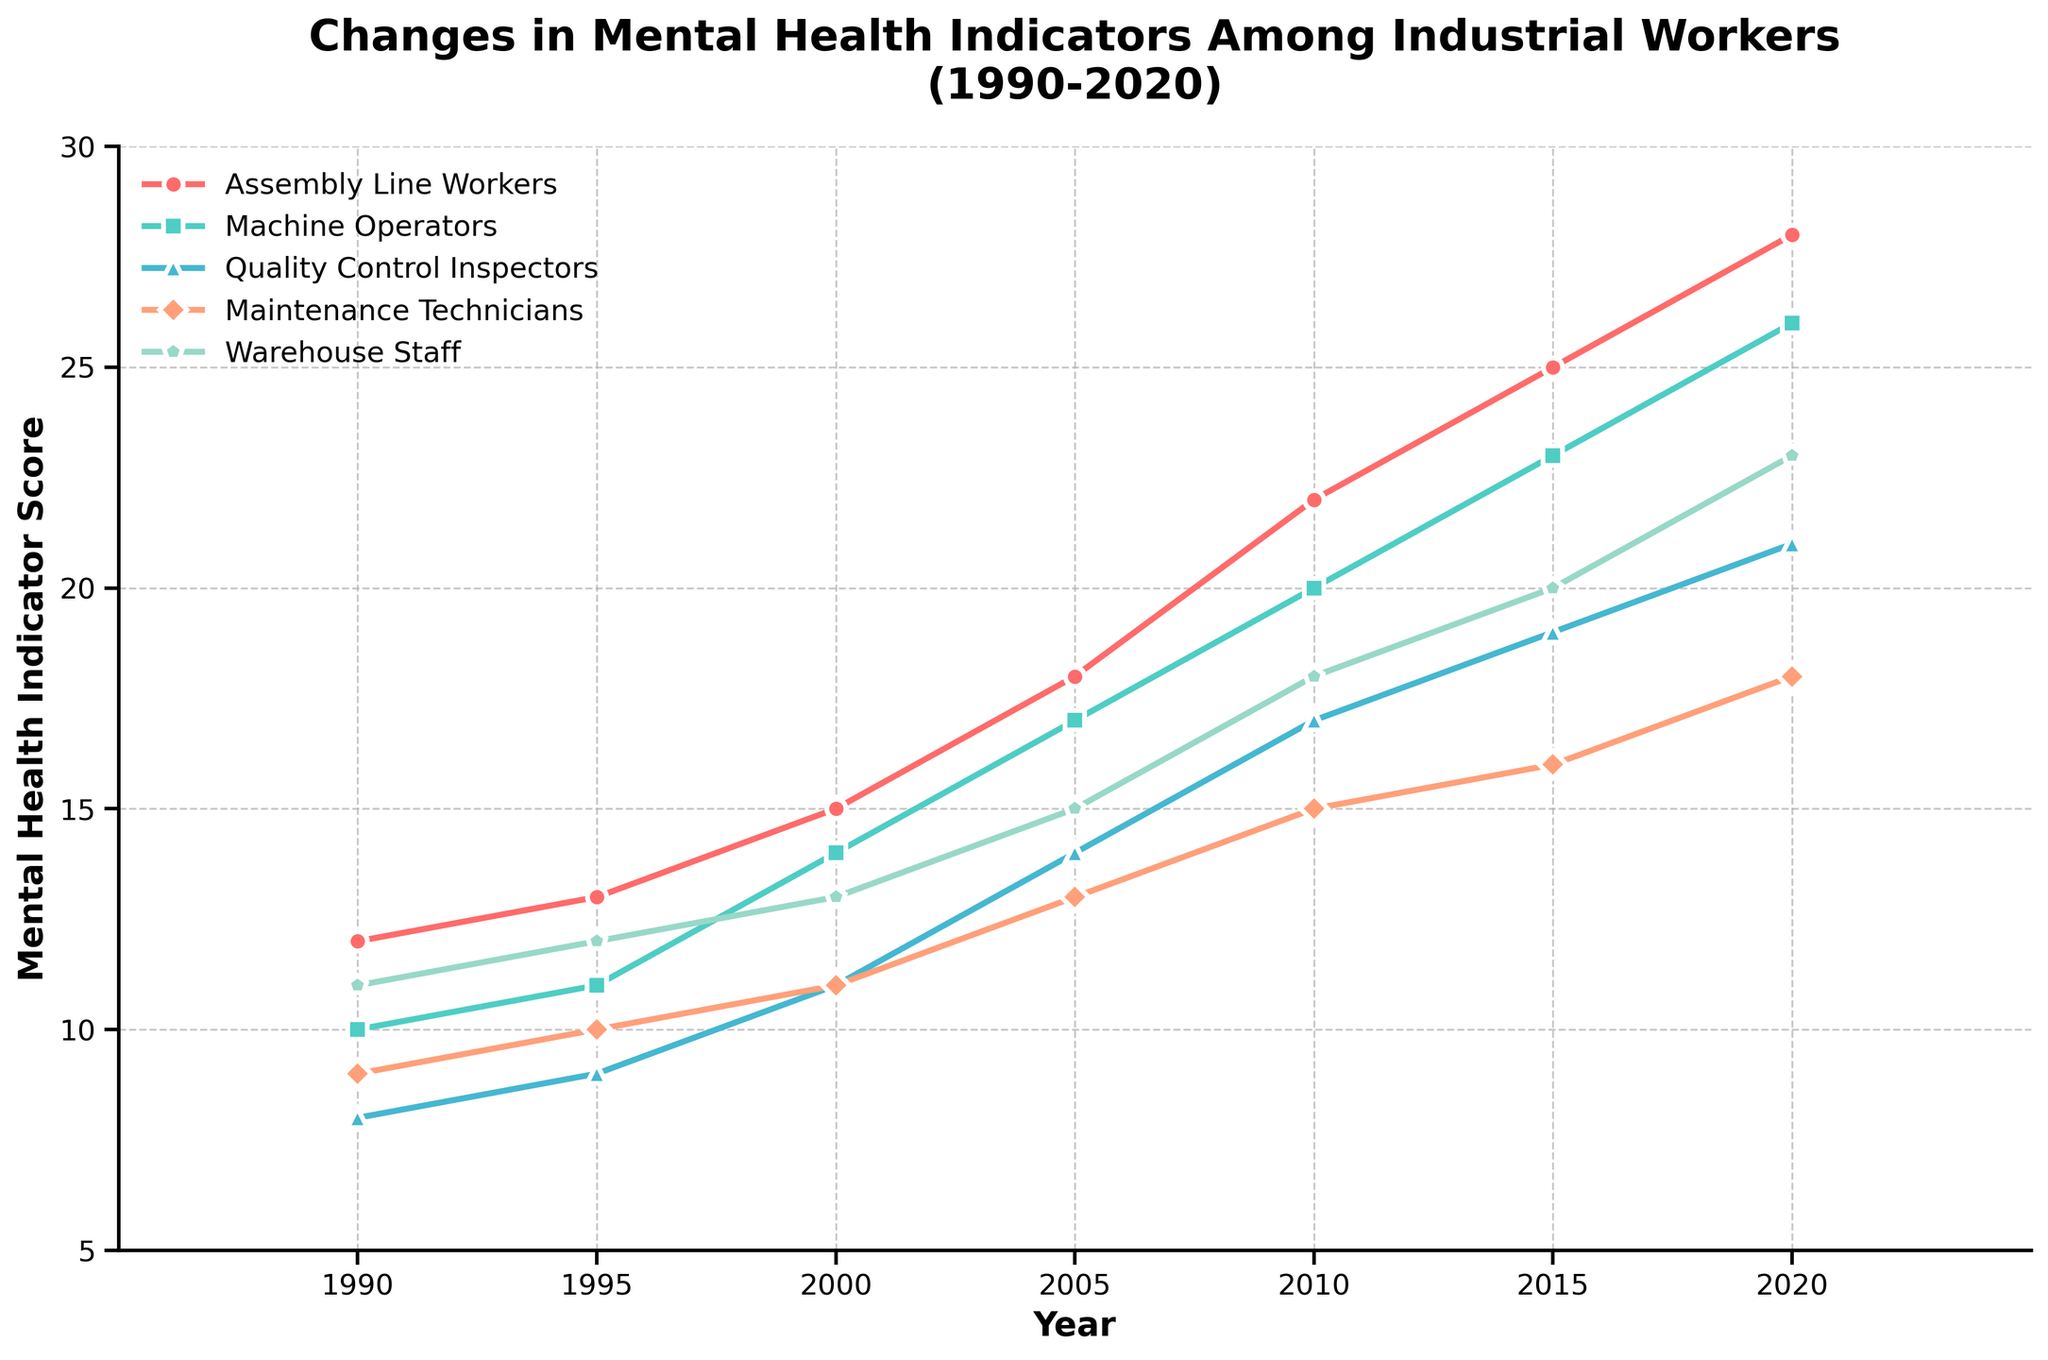Which job role has the highest mental health indicator score in 2020? Look at the values for the year 2020 for each job role. Assembly Line Workers have a score of 28, which is the highest among the job roles listed.
Answer: Assembly Line Workers How did the mental health indicator for Machine Operators change from 1990 to 2020? The mental health indicator score for Machine Operators in 1990 was 10, and in 2020, it is 26. The change is calculated by subtracting the initial value from the final value: 26 - 10 = 16.
Answer: Increased by 16 What's the average mental health indicator score for Warehouse Staff over the years? The scores for Warehouse Staff over the years are 11, 12, 13, 15, 18, 20, and 23. Adding them together gives 112. Divide the sum by the number of years (7) to get the average: 112 / 7 = 16.
Answer: 16 Which job roles saw an increase in their mental health indicator score from 2015 to 2020? Compare the scores in 2015 and 2020 for each job role. Assembly Line Workers increased from 25 to 28, Machine Operators from 23 to 26, Quality Control Inspectors from 19 to 21, Maintenance Technicians from 16 to 18, and Warehouse Staff from 20 to 23. Therefore, all job roles saw an increase.
Answer: All job roles In which year do the mental health indicators for Assembly Line Workers first surpass 20 points? Check the values for Assembly Line Workers year by year. The first year the score exceeds 20 points is 2010, with a score of 22.
Answer: 2010 Compare the mental health indicator scores between Maintenance Technicians and Quality Control Inspectors in 2005. Which group had a higher score, and by how much? In 2005, Maintenance Technicians had a score of 13, and Quality Control Inspectors had a score of 14. The difference is 14 - 13 = 1, with Quality Control Inspectors having the higher score.
Answer: Quality Control Inspectors by 1 point What is the trend of mental health indicators for Assembly Line Workers from 1990 to 2020? Observing the pattern of scores for Assembly Line Workers, we see a steady increase from 12 in 1990 to 28 in 2020, indicating a rising trend.
Answer: Rising By how much did the mental health indicator score of Warehouse Staff change from 2000 to 2020? For Warehouse Staff, the score in 2000 was 13, and in 2020 it was 23. The change is calculated as 23 - 13 = 10.
Answer: Increased by 10 What is the sum of the mental health indicator scores for Machine Operators across all years provided? Adding the scores for Machine Operators: 10 + 11 + 14 + 17 + 20 + 23 + 26, we get a total of 121.
Answer: 121 How does the mental health indicator score of Quality Control Inspectors in 2010 compare to that in 1990? The score for Quality Control Inspectors was 8 in 1990 and 17 in 2010. The difference is 17 - 8 = 9, with the score increasing by 9 points.
Answer: Increased by 9 points 